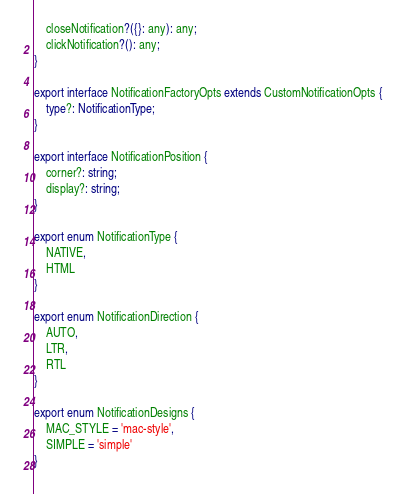Convert code to text. <code><loc_0><loc_0><loc_500><loc_500><_TypeScript_>    closeNotification?({}: any): any;
    clickNotification?(): any;
}

export interface NotificationFactoryOpts extends CustomNotificationOpts {
    type?: NotificationType;
}

export interface NotificationPosition {
    corner?: string;
    display?: string;
}

export enum NotificationType {
    NATIVE,
    HTML
}

export enum NotificationDirection {
    AUTO,
    LTR,
    RTL
}

export enum NotificationDesigns {
    MAC_STYLE = 'mac-style',
    SIMPLE = 'simple'
}
</code> 